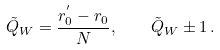Convert formula to latex. <formula><loc_0><loc_0><loc_500><loc_500>\tilde { Q } _ { W } = \frac { r _ { 0 } ^ { ^ { \prime } } - r _ { 0 } } { N } , \, \quad \tilde { Q } _ { W } \pm 1 \, .</formula> 